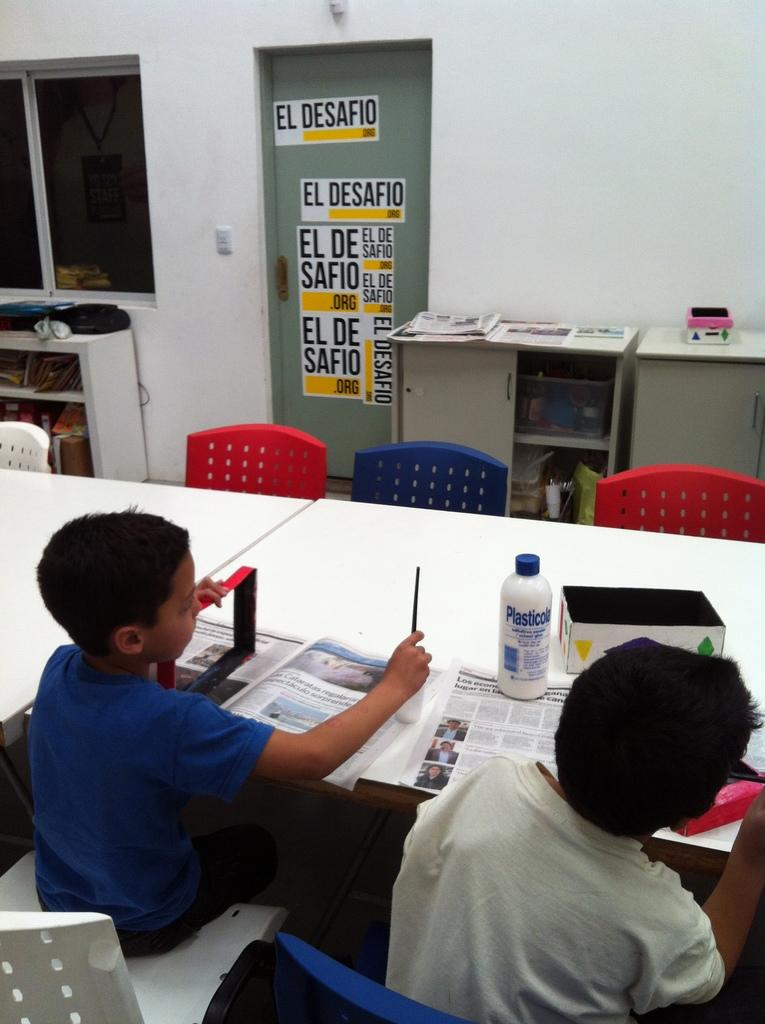<image>
Create a compact narrative representing the image presented. Two kids are sitting on a white desks in a classom with a door covered with "El Desafio" stickers. 